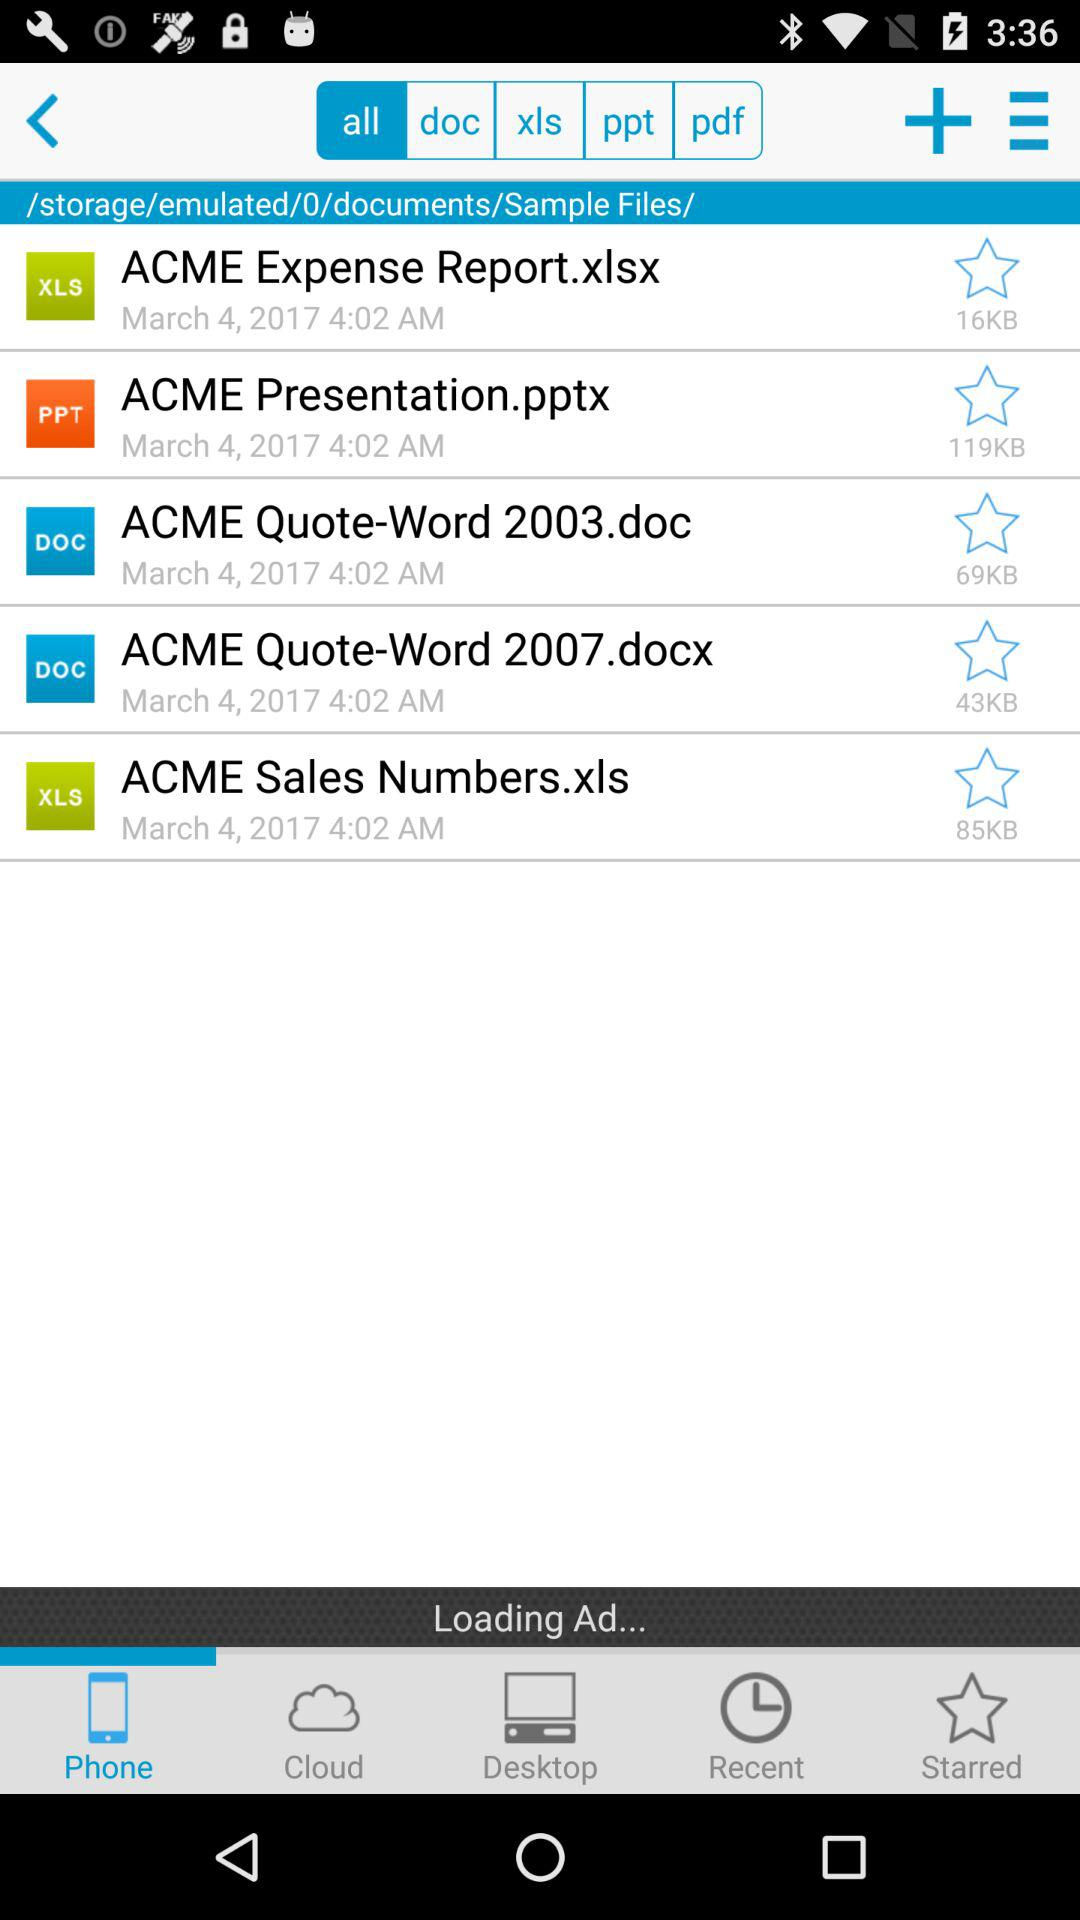How much storage space is taken by the file "ACME Expense Report.xlsx"? The storage space taken by the file "ACME Expense Report.xlsx" is 16 KB. 